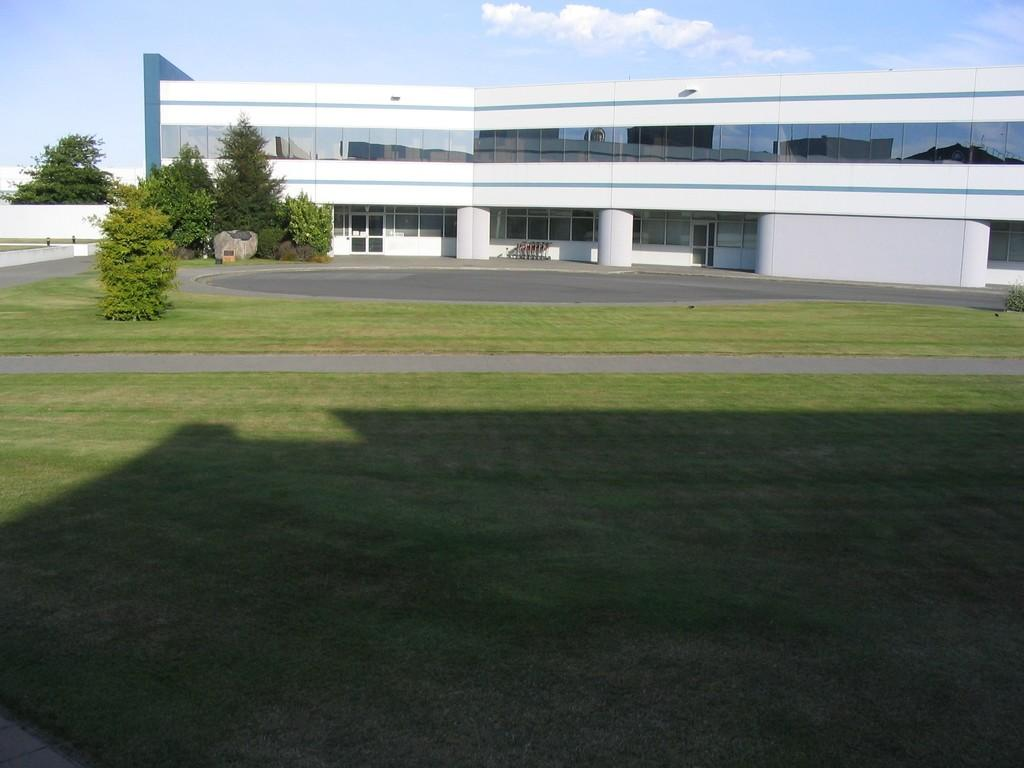What type of vegetation is visible in the foreground of the picture? There is grass in the foreground of the picture. What can be seen in the center of the picture? There are trees, grass, windows, a wall, a road, and a building in the center of the picture. What is the weather like in the image? The weather is sunny in the image. Where is the playground located in the image? There is no playground present in the image. What type of skin condition can be seen on the trees in the image? There is no mention of any skin condition on the trees in the image; they appear to be healthy. 